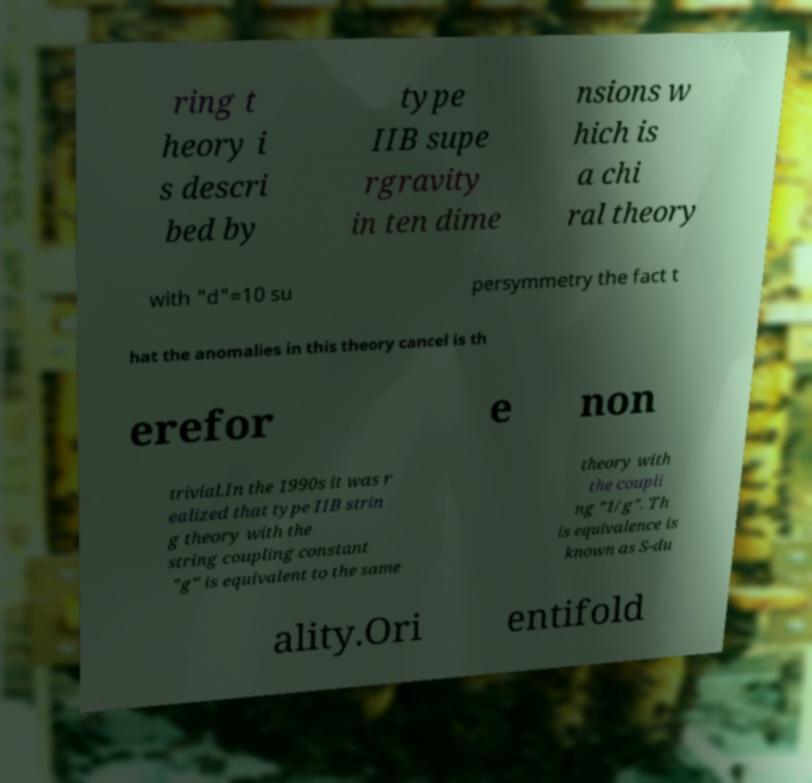Please identify and transcribe the text found in this image. ring t heory i s descri bed by type IIB supe rgravity in ten dime nsions w hich is a chi ral theory with "d"=10 su persymmetry the fact t hat the anomalies in this theory cancel is th erefor e non trivial.In the 1990s it was r ealized that type IIB strin g theory with the string coupling constant "g" is equivalent to the same theory with the coupli ng "1/g". Th is equivalence is known as S-du ality.Ori entifold 